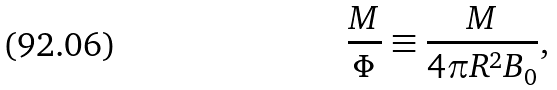<formula> <loc_0><loc_0><loc_500><loc_500>\frac { M } { \Phi } \equiv \frac { M } { 4 \pi R ^ { 2 } B _ { 0 } } ,</formula> 